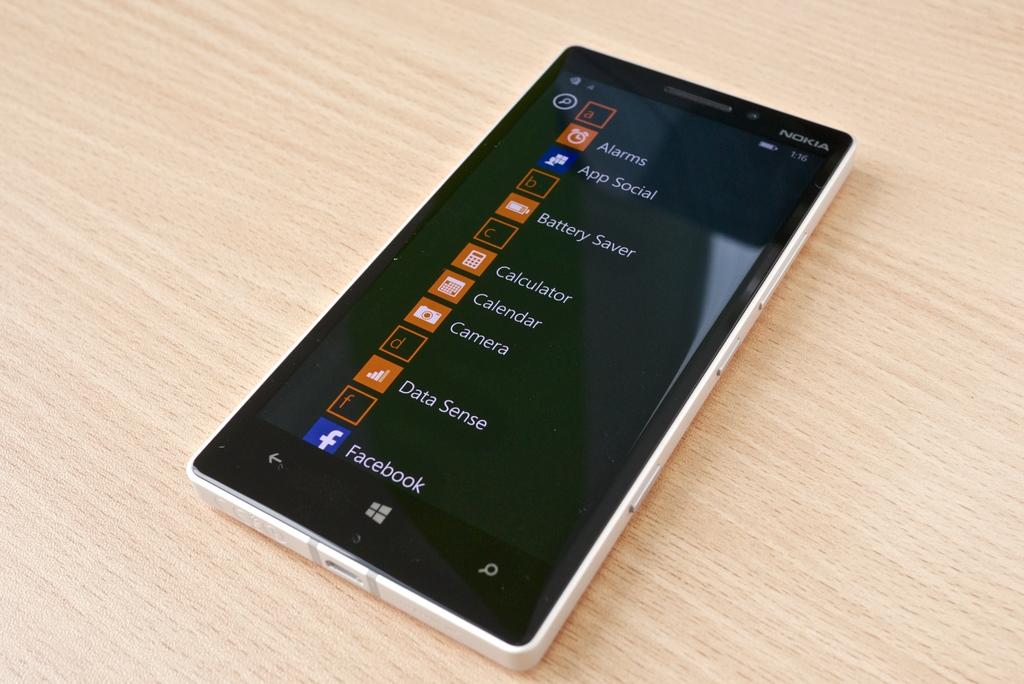Provide a one-sentence caption for the provided image. A smart phone with alarms on the top of the list. 